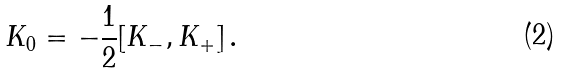Convert formula to latex. <formula><loc_0><loc_0><loc_500><loc_500>K _ { 0 } = - \frac { 1 } { 2 } [ K _ { - } , K _ { + } ] \, .</formula> 